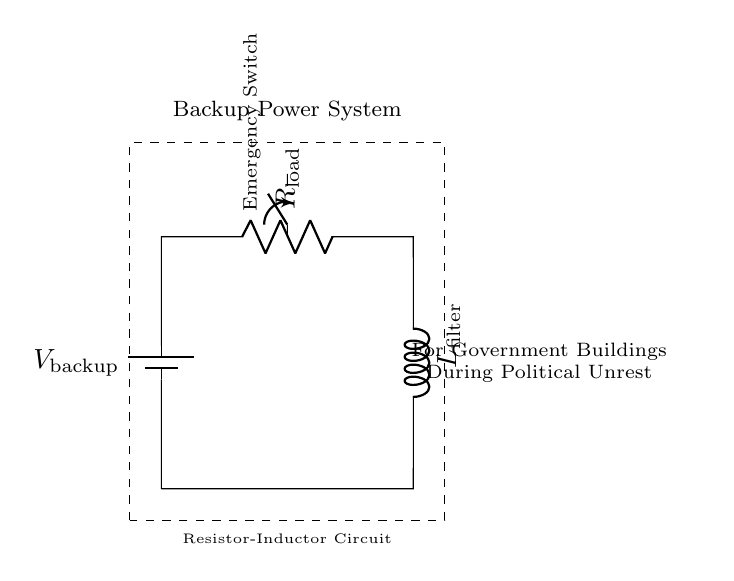What is the primary purpose of this circuit? The circuit is designed as a backup power system for government buildings during situations of political unrest. This is indicated by the label in the circuit diagram, which specifies its application context.
Answer: Backup power system What component generates the power in this circuit? The power is generated by the battery, which is labeled as V backup in the circuit. It provides the necessary voltage for the operation of other components in the circuit.
Answer: Battery How many primary components are in this circuit? There are three primary components: one battery, one resistor, and one inductor, which are interconnected to form the complete circuit.
Answer: Three What is the role of the resistor in this circuit? The resistor, labeled as R load, typically limits the current flowing through the circuit, ensuring that the system can operate safely and effectively under the specified load conditions.
Answer: Limit current What happens to current when the emergency switch is turned on? When the emergency switch is turned on, it closes the circuit, allowing current to flow from the battery through the resistor and inductor, activating the backup power system. The switch connects the circuit to the voltage source, enhancing operational readiness.
Answer: Current flows In what scenario would this circuit be activated? This circuit would be activated during political unrest or emergencies, as indicated by its designation for government buildings to ensure continued power supply when the main source may be compromised.
Answer: Political unrest 